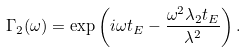Convert formula to latex. <formula><loc_0><loc_0><loc_500><loc_500>\Gamma _ { 2 } ( \omega ) = \exp \left ( i \omega t _ { E } - \frac { \omega ^ { 2 } \lambda _ { 2 } t _ { E } } { \lambda ^ { 2 } } \right ) .</formula> 